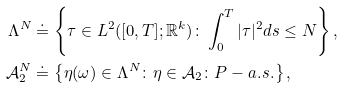<formula> <loc_0><loc_0><loc_500><loc_500>\Lambda ^ { N } & \doteq \left \{ { \tau } \in L ^ { 2 } ( [ 0 , T ] ; { \mathbb { R } } ^ { k } ) \colon \int _ { 0 } ^ { T } | \tau | ^ { 2 } d s \leq N \right \} , \\ { \mathcal { A } } ^ { N } _ { 2 } & \doteq \left \{ \eta ( \omega ) \in \Lambda ^ { N } \colon \eta \in { \mathcal { A } } _ { 2 } \colon P - a . s . \right \} ,</formula> 